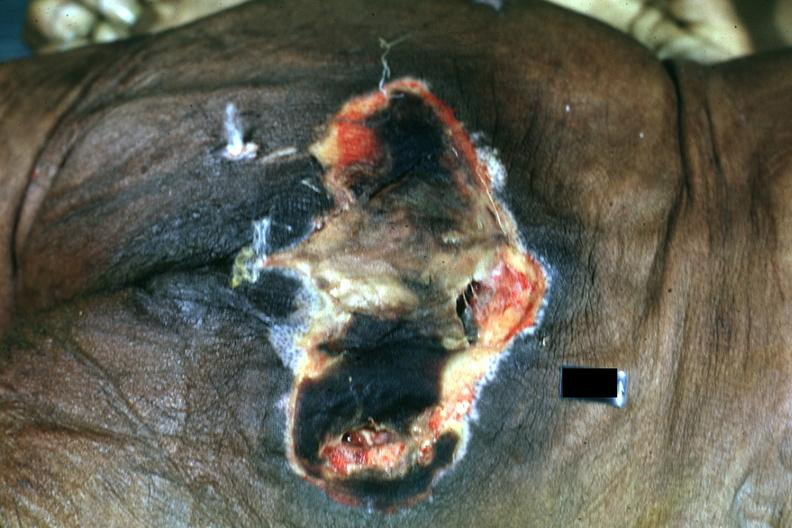what does this image show?
Answer the question using a single word or phrase. Large necrotic ulcer over sacrum 